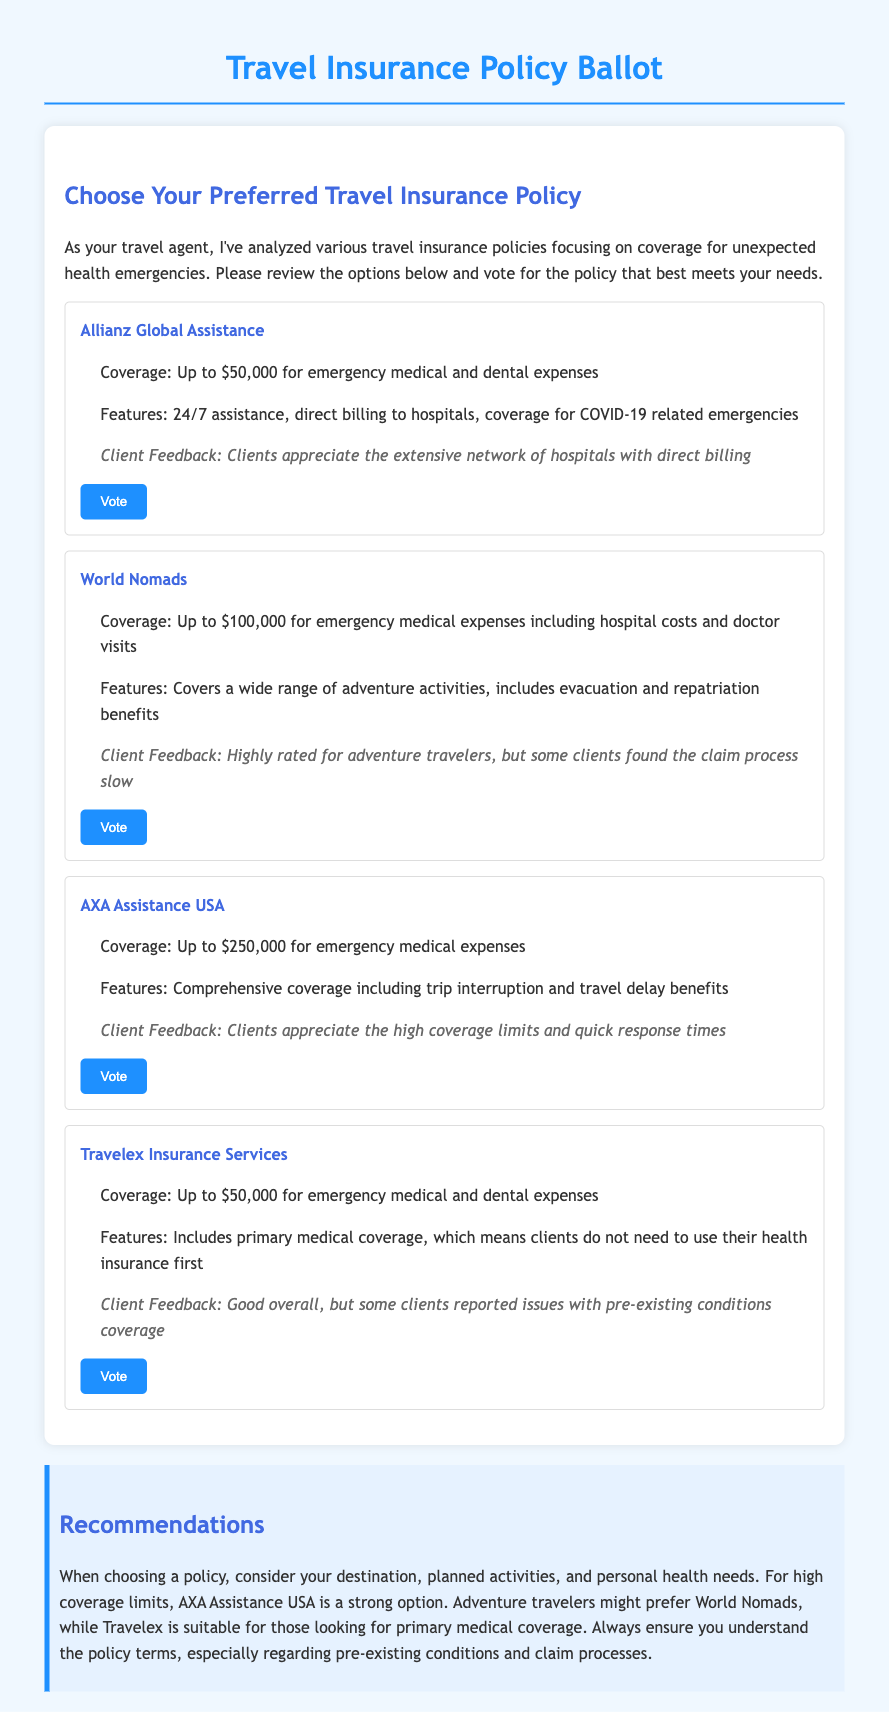What is the coverage amount for Allianz Global Assistance? The coverage amount for Allianz Global Assistance is stated in the document as "Up to $50,000 for emergency medical and dental expenses."
Answer: Up to $50,000 What is a feature of World Nomads? The document provides information on features of World Nomads, including "Covers a wide range of adventure activities, includes evacuation and repatriation benefits."
Answer: Includes evacuation and repatriation benefits How much coverage does AXA Assistance USA provide? The document specifies that AXA Assistance USA offers "Up to $250,000 for emergency medical expenses."
Answer: Up to $250,000 What do clients appreciate about AXA Assistance USA? The client feedback states "Clients appreciate the high coverage limits and quick response times."
Answer: High coverage limits and quick response times Which insurance policy is suggested for adventure travelers? Based on the analysis presented in the document, "World Nomads" is positioned as a suitable option for adventure travelers.
Answer: World Nomads What client feedback is given for Travelex Insurance Services? The document mentions, "Good overall, but some clients reported issues with pre-existing conditions coverage."
Answer: Issues with pre-existing conditions coverage What is the purpose of this document? This document is a "Travel Insurance Policy Ballot" aimed at helping clients choose an insurance policy.
Answer: Travel Insurance Policy Ballot What is a unique feature of Travelex Insurance Services? The document notes that Travelex includes "primary medical coverage."
Answer: Primary medical coverage What does the conclusion recommend regarding AXA Assistance USA? The conclusion states, "For high coverage limits, AXA Assistance USA is a strong option."
Answer: A strong option 